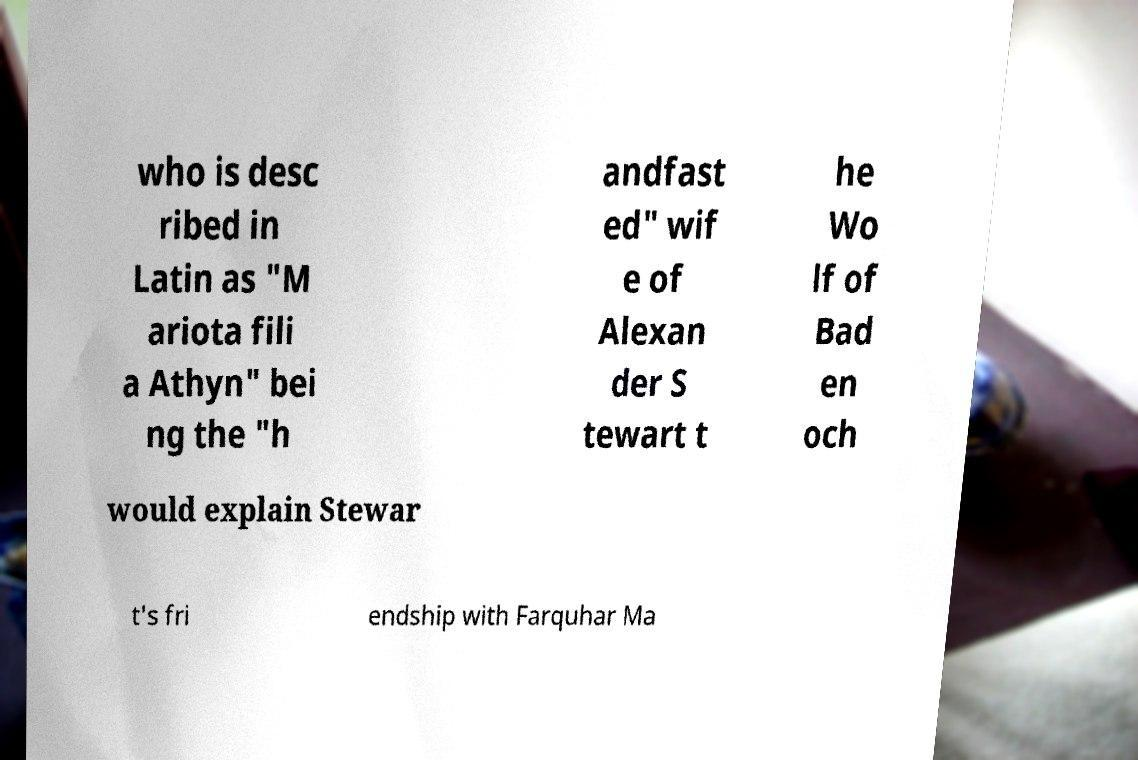Can you accurately transcribe the text from the provided image for me? who is desc ribed in Latin as "M ariota fili a Athyn" bei ng the "h andfast ed" wif e of Alexan der S tewart t he Wo lf of Bad en och would explain Stewar t's fri endship with Farquhar Ma 